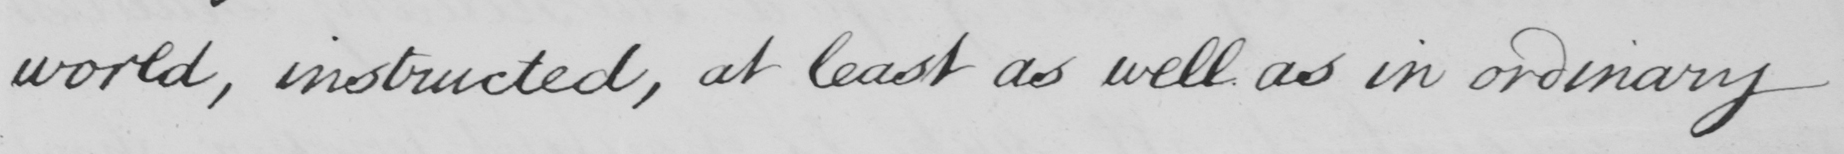Can you tell me what this handwritten text says? world , instructed , at least as well as in ordinary 